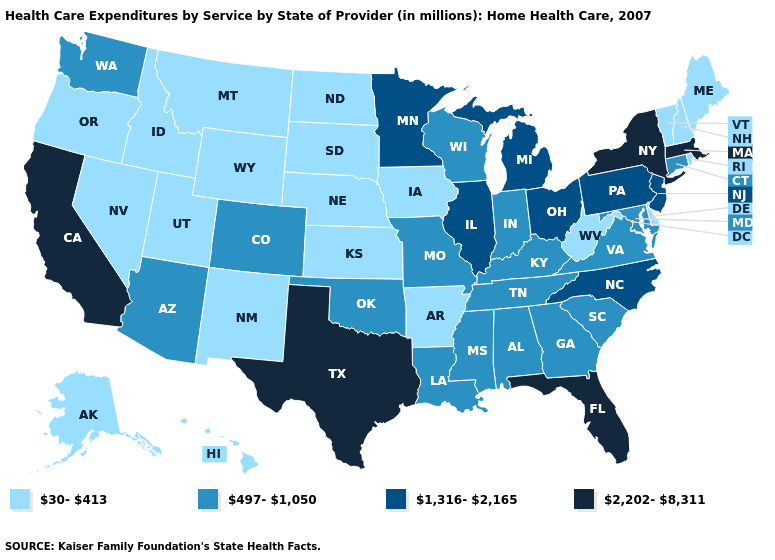Does Michigan have the same value as Hawaii?
Concise answer only. No. Does Washington have the same value as Maryland?
Answer briefly. Yes. What is the highest value in states that border New Hampshire?
Keep it brief. 2,202-8,311. What is the value of North Dakota?
Give a very brief answer. 30-413. Among the states that border Delaware , does Maryland have the highest value?
Concise answer only. No. Does Connecticut have the highest value in the USA?
Quick response, please. No. Name the states that have a value in the range 30-413?
Concise answer only. Alaska, Arkansas, Delaware, Hawaii, Idaho, Iowa, Kansas, Maine, Montana, Nebraska, Nevada, New Hampshire, New Mexico, North Dakota, Oregon, Rhode Island, South Dakota, Utah, Vermont, West Virginia, Wyoming. Does the first symbol in the legend represent the smallest category?
Short answer required. Yes. What is the highest value in the MidWest ?
Write a very short answer. 1,316-2,165. Does New Hampshire have a higher value than Alabama?
Concise answer only. No. Does Texas have the same value as New York?
Concise answer only. Yes. Among the states that border Idaho , does Washington have the highest value?
Answer briefly. Yes. Name the states that have a value in the range 2,202-8,311?
Quick response, please. California, Florida, Massachusetts, New York, Texas. What is the lowest value in the USA?
Be succinct. 30-413. Is the legend a continuous bar?
Concise answer only. No. 